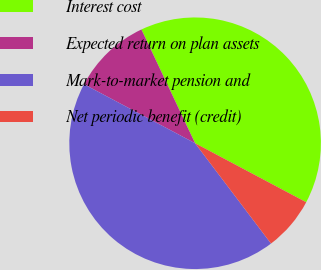Convert chart to OTSL. <chart><loc_0><loc_0><loc_500><loc_500><pie_chart><fcel>Interest cost<fcel>Expected return on plan assets<fcel>Mark-to-market pension and<fcel>Net periodic benefit (credit)<nl><fcel>39.79%<fcel>10.21%<fcel>43.08%<fcel>6.92%<nl></chart> 